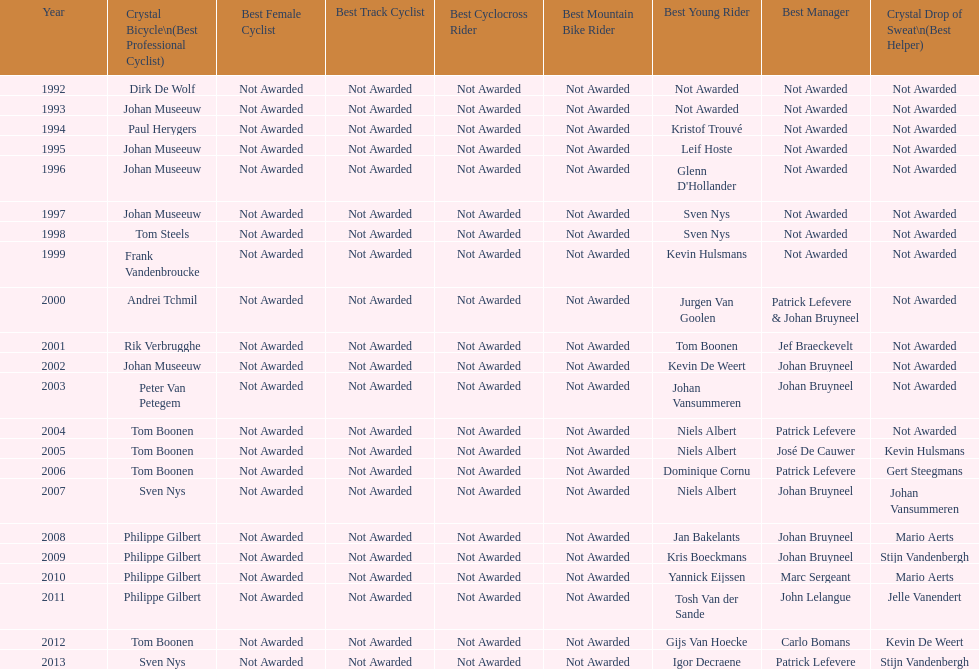Who won the crystal bicycle earlier, boonen or nys? Tom Boonen. 